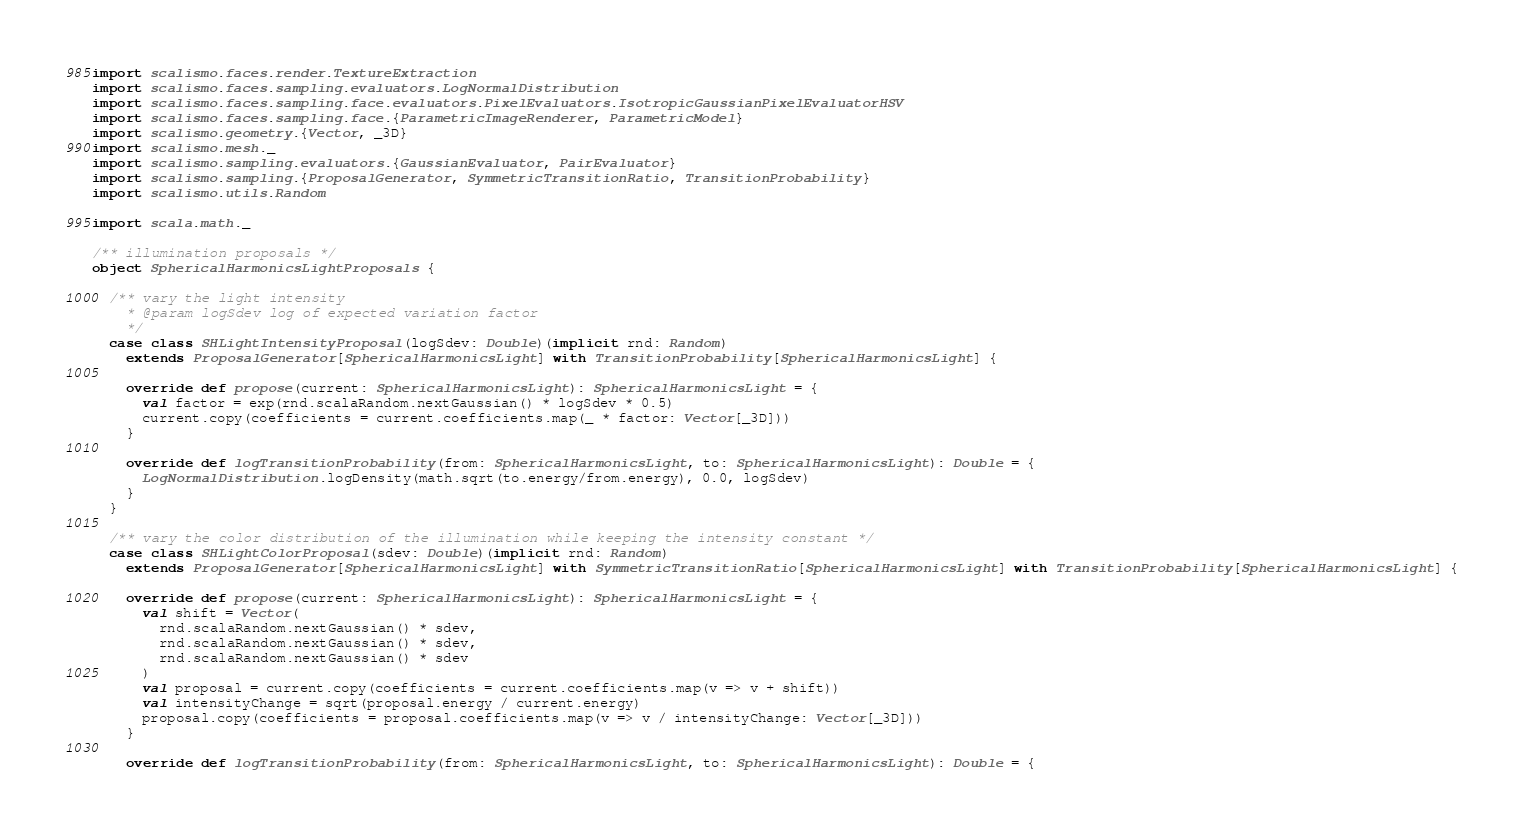<code> <loc_0><loc_0><loc_500><loc_500><_Scala_>import scalismo.faces.render.TextureExtraction
import scalismo.faces.sampling.evaluators.LogNormalDistribution
import scalismo.faces.sampling.face.evaluators.PixelEvaluators.IsotropicGaussianPixelEvaluatorHSV
import scalismo.faces.sampling.face.{ParametricImageRenderer, ParametricModel}
import scalismo.geometry.{Vector, _3D}
import scalismo.mesh._
import scalismo.sampling.evaluators.{GaussianEvaluator, PairEvaluator}
import scalismo.sampling.{ProposalGenerator, SymmetricTransitionRatio, TransitionProbability}
import scalismo.utils.Random

import scala.math._

/** illumination proposals */
object SphericalHarmonicsLightProposals {

  /** vary the light intensity
    * @param logSdev log of expected variation factor
    */
  case class SHLightIntensityProposal(logSdev: Double)(implicit rnd: Random)
    extends ProposalGenerator[SphericalHarmonicsLight] with TransitionProbability[SphericalHarmonicsLight] {

    override def propose(current: SphericalHarmonicsLight): SphericalHarmonicsLight = {
      val factor = exp(rnd.scalaRandom.nextGaussian() * logSdev * 0.5)
      current.copy(coefficients = current.coefficients.map(_ * factor: Vector[_3D]))
    }

    override def logTransitionProbability(from: SphericalHarmonicsLight, to: SphericalHarmonicsLight): Double = {
      LogNormalDistribution.logDensity(math.sqrt(to.energy/from.energy), 0.0, logSdev)
    }
  }

  /** vary the color distribution of the illumination while keeping the intensity constant */
  case class SHLightColorProposal(sdev: Double)(implicit rnd: Random)
    extends ProposalGenerator[SphericalHarmonicsLight] with SymmetricTransitionRatio[SphericalHarmonicsLight] with TransitionProbability[SphericalHarmonicsLight] {

    override def propose(current: SphericalHarmonicsLight): SphericalHarmonicsLight = {
      val shift = Vector(
        rnd.scalaRandom.nextGaussian() * sdev,
        rnd.scalaRandom.nextGaussian() * sdev,
        rnd.scalaRandom.nextGaussian() * sdev
      )
      val proposal = current.copy(coefficients = current.coefficients.map(v => v + shift))
      val intensityChange = sqrt(proposal.energy / current.energy)
      proposal.copy(coefficients = proposal.coefficients.map(v => v / intensityChange: Vector[_3D]))
    }

    override def logTransitionProbability(from: SphericalHarmonicsLight, to: SphericalHarmonicsLight): Double = {</code> 